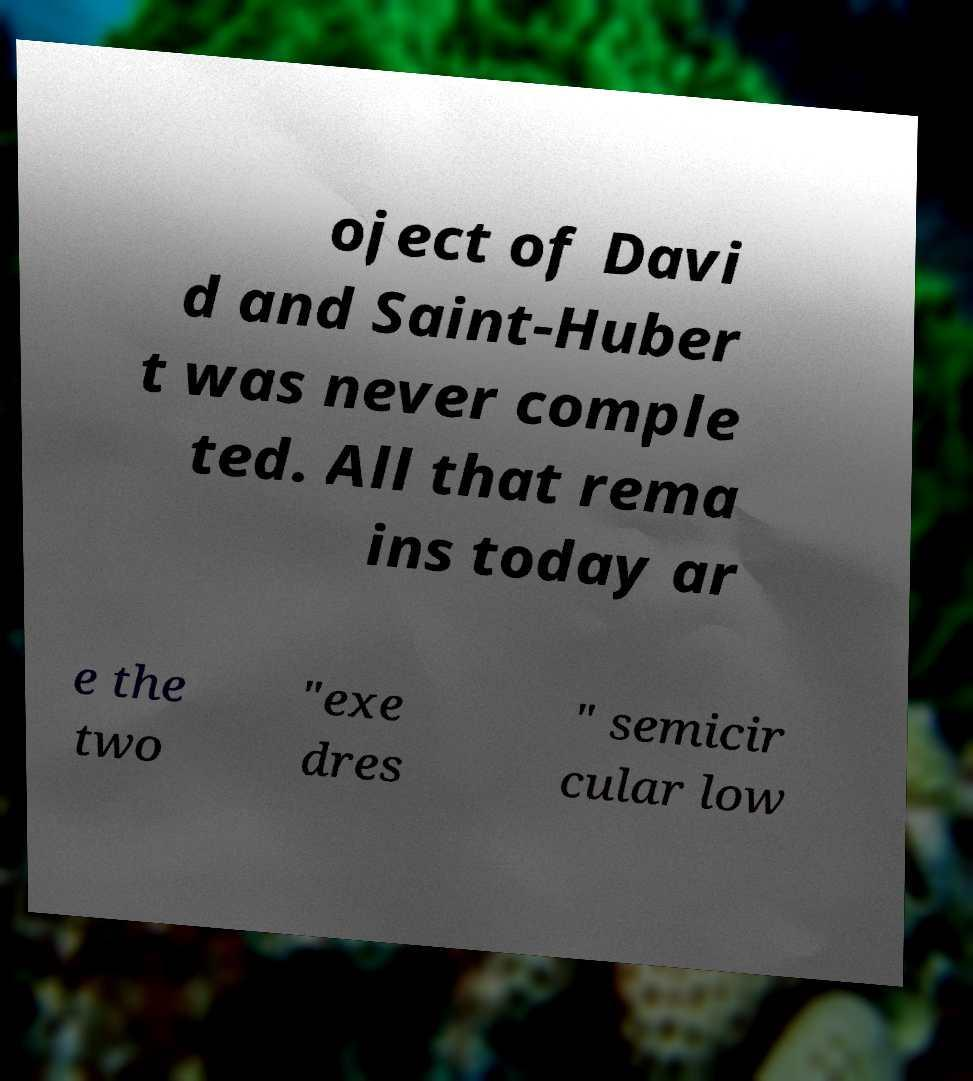Can you accurately transcribe the text from the provided image for me? oject of Davi d and Saint-Huber t was never comple ted. All that rema ins today ar e the two "exe dres " semicir cular low 